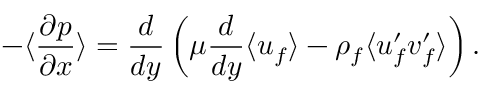Convert formula to latex. <formula><loc_0><loc_0><loc_500><loc_500>- \langle \frac { \partial p } { \partial x } \rangle = \frac { d } { d y } \left ( \mu \frac { d } { d y } \langle u _ { f } \rangle - \rho _ { f } \langle u _ { f } ^ { \prime } v _ { f } ^ { \prime } \rangle \right ) .</formula> 